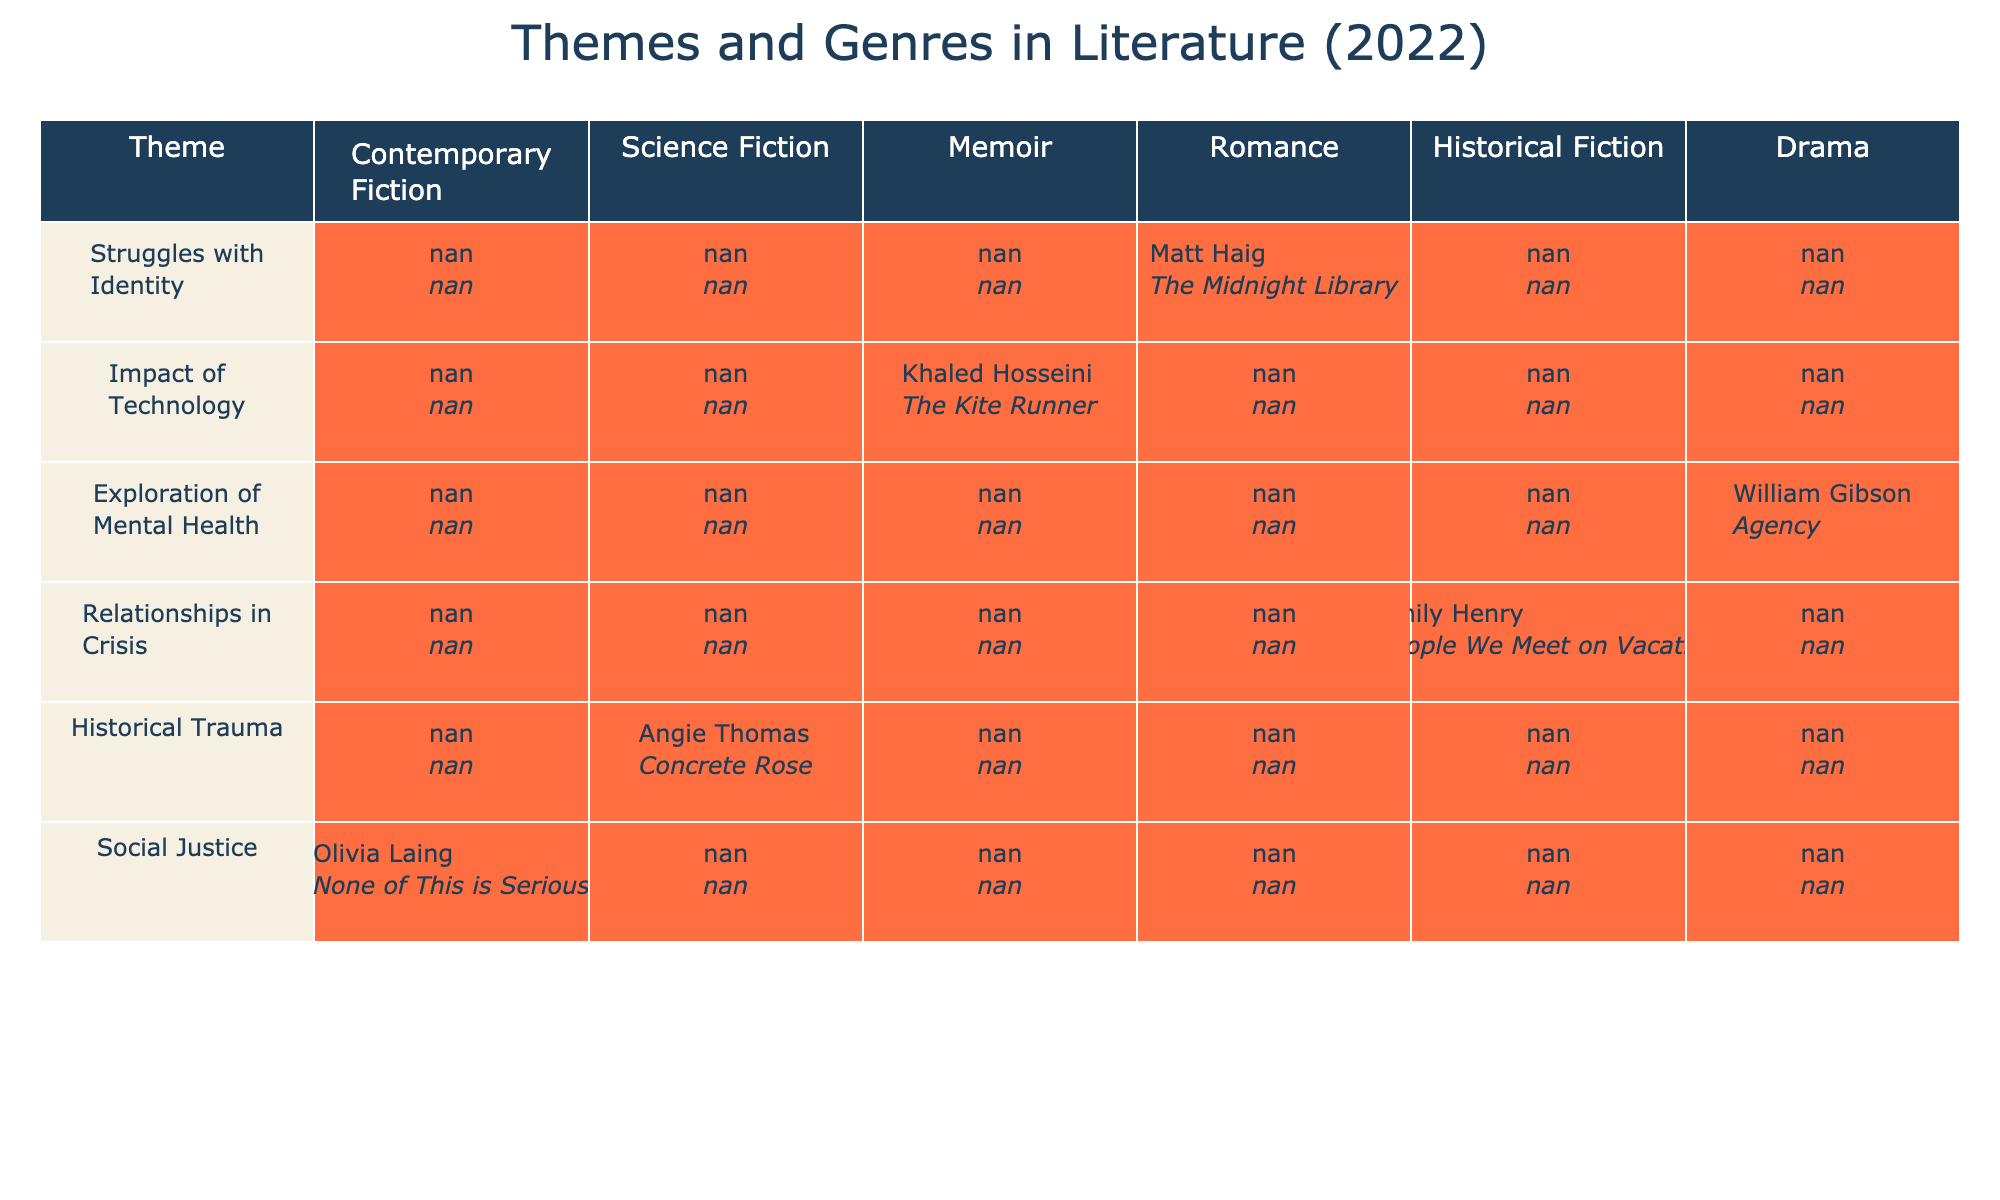What notable work is associated with the theme "Struggles with Identity"? In the table, we look at the row for the theme "Struggles with Identity" and identify the corresponding notable work listed under that theme, which is "None of This is Serious."
Answer: None of This is Serious Which genre does Khaled Hosseini's notable work belong to? By examining the row for Khaled Hosseini, we see that his notable work "The Kite Runner" is categorized under the genre "Historical Fiction."
Answer: Historical Fiction Is there a memoir that explores mental health in 2022? We can verify this by checking the table for any mentions of the genre "Memoir" associated with the theme "Exploration of Mental Health." The entry confirms that there is a notable memoir, "The Midnight Library," by Matt Haig.
Answer: Yes How many themes are associated with the genre of Science Fiction? We need to count the number of rows that list a genre as "Science Fiction." Looking at the table, we find only one entry, which connects the theme "Impact of Technology" with the genre of Science Fiction. Therefore, the total is 1.
Answer: 1 What is the relationship between social justice and notable authors in 2022? Here, we examine our table and note that the theme "Social Justice" is represented by the notable author Angie Thomas. This indicates that the focus on social justice in 2022 is linked to Angie Thomas as an author.
Answer: Angie Thomas How does the number of Romance authors compare to those focusing on Historical Trauma? To find this comparison, we note that there is one Romance author (Emily Henry) and one author focusing on Historical Trauma (Khaled Hosseini). Therefore, there are an equal number of authors—one for each theme.
Answer: They are equal Which author has works listed across two genres, and what are those genres? In the table, only one author appears with works categorized under multiple genres. However, upon inspection, we find that each author is tied to a single genre. Thus, there are no authors listed across two genres in this dataset.
Answer: No Is there a notable work that deals with relationships in crisis in 2022? To confirm this, we check if the table features a work related to the theme "Relationships in Crisis." The entry shows that "People We Meet on Vacation" by Emily Henry addresses this theme.
Answer: Yes What theme has the most notable works listed in the table? We analyze the table for themes that have multiple favorable authors and notable works. Upon examining the table, we find that each theme only has one work linked to it. Therefore, no theme is associated with more than one work.
Answer: All themes have one work 